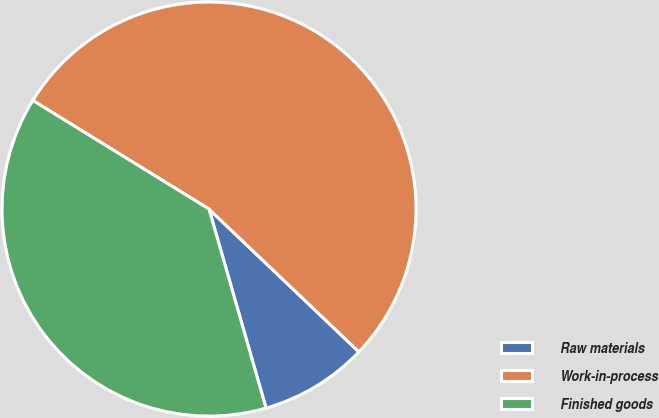<chart> <loc_0><loc_0><loc_500><loc_500><pie_chart><fcel>Raw materials<fcel>Work-in-process<fcel>Finished goods<nl><fcel>8.44%<fcel>53.32%<fcel>38.23%<nl></chart> 